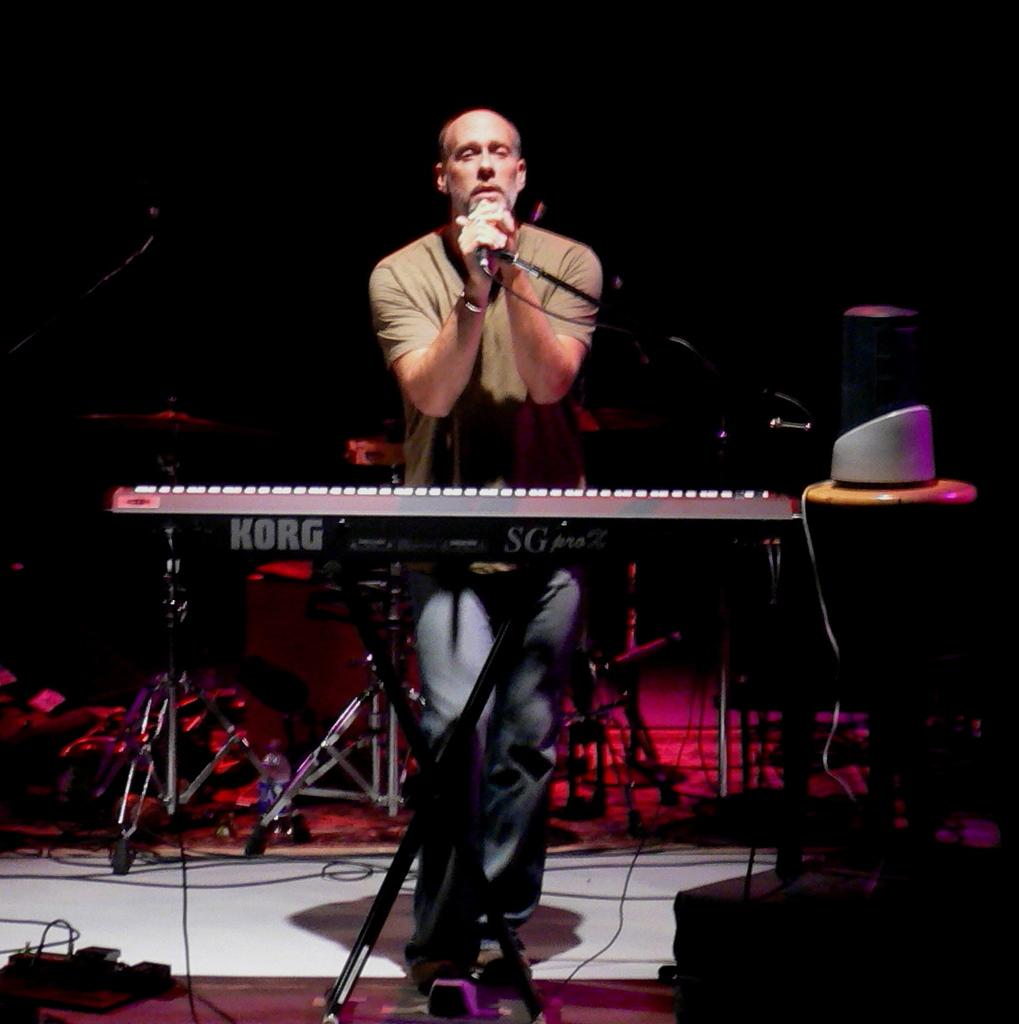What is the man in the image doing? The man is standing in the image. What object is the man holding in his hand? The man is holding a microphone in his hand. What musical instrument can be seen in the image? There is a musical keyboard in the front of the image. What type of mass is the man attending in the image? There is no indication of a mass or gathering in the image; it simply shows a man holding a microphone and a musical keyboard in front of him. 